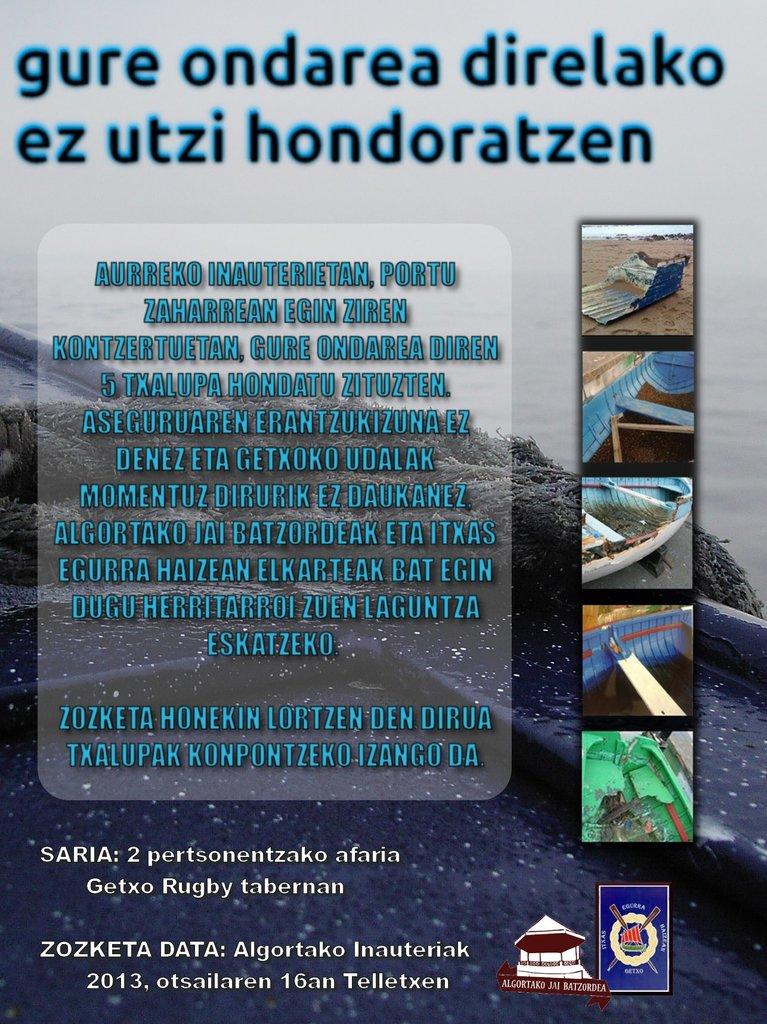When was this made?
Make the answer very short. 2013. 